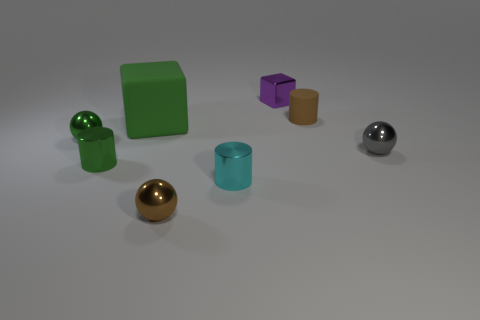Are there any other things that are the same shape as the big thing?
Make the answer very short. Yes. The block that is the same material as the gray object is what color?
Your answer should be very brief. Purple. There is a block that is in front of the brown object on the right side of the small brown ball; is there a brown matte cylinder that is in front of it?
Provide a succinct answer. No. Is the number of shiny cylinders that are in front of the tiny cyan cylinder less than the number of purple cubes behind the small green cylinder?
Give a very brief answer. Yes. What number of tiny green objects are made of the same material as the tiny block?
Your answer should be very brief. 2. There is a green rubber cube; does it have the same size as the cylinder that is behind the gray shiny object?
Give a very brief answer. No. What material is the tiny cylinder that is the same color as the big object?
Ensure brevity in your answer.  Metal. There is a sphere that is to the right of the brown object that is in front of the tiny sphere behind the gray sphere; what size is it?
Provide a succinct answer. Small. Are there more small cyan metal cylinders on the left side of the brown sphere than green cubes in front of the tiny cube?
Give a very brief answer. No. There is a small shiny ball on the left side of the large matte cube; how many green objects are behind it?
Your answer should be compact. 1. 